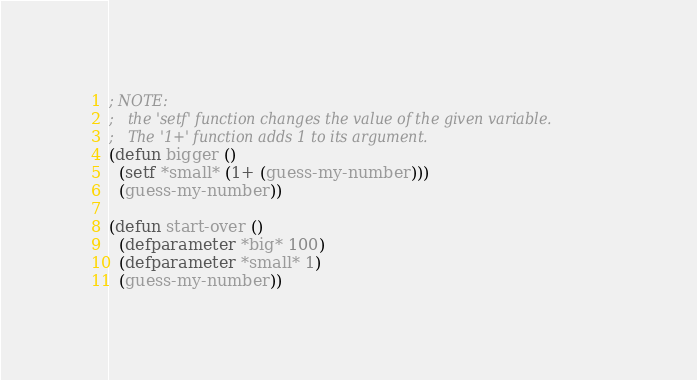<code> <loc_0><loc_0><loc_500><loc_500><_Lisp_>; NOTE:
;   the 'setf' function changes the value of the given variable. 
;   The '1+' function adds 1 to its argument.
(defun bigger ()
  (setf *small* (1+ (guess-my-number)))
  (guess-my-number))

(defun start-over ()
  (defparameter *big* 100)
  (defparameter *small* 1)
  (guess-my-number))
</code> 